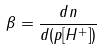Convert formula to latex. <formula><loc_0><loc_0><loc_500><loc_500>\beta = \frac { d n } { d ( p [ H ^ { + } ] ) }</formula> 